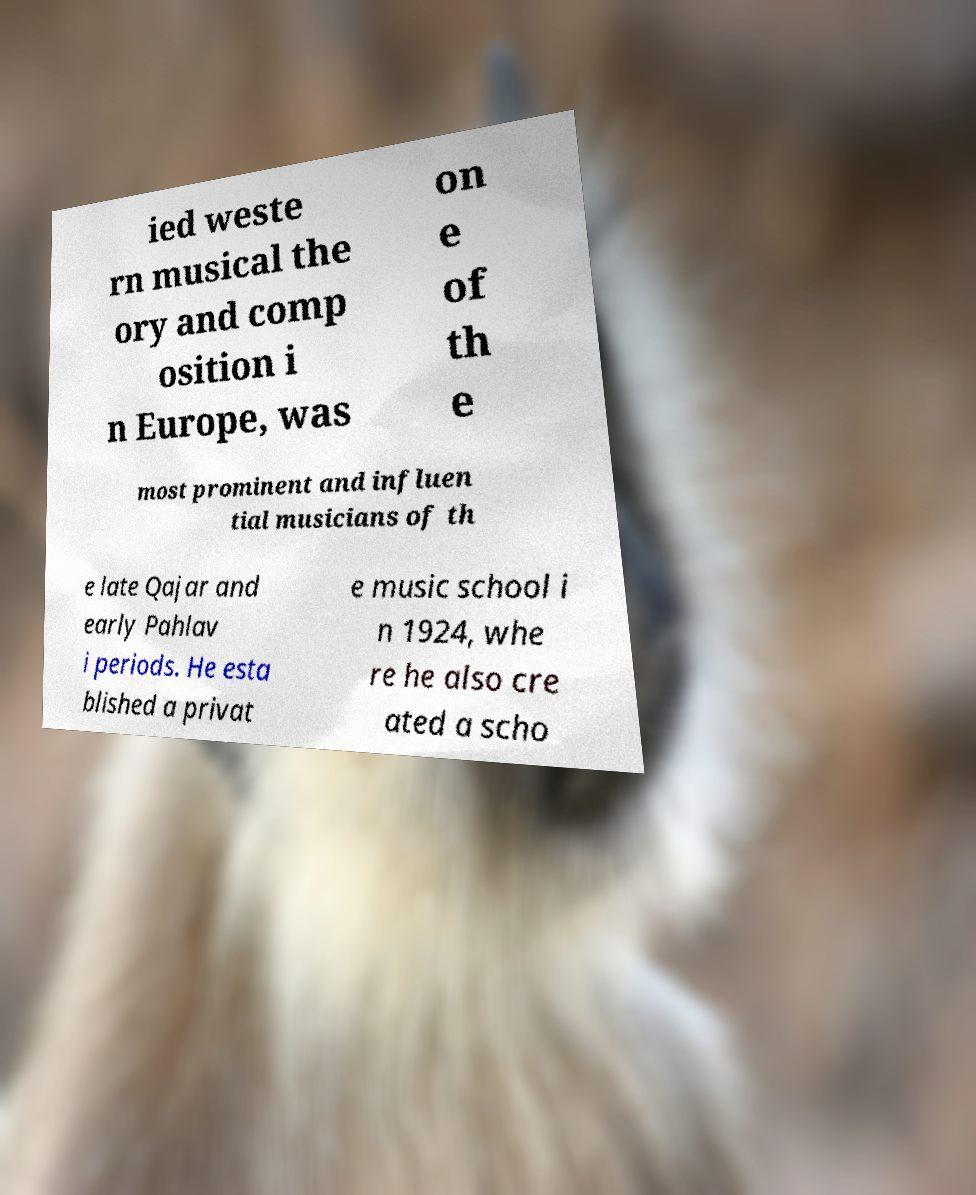Could you assist in decoding the text presented in this image and type it out clearly? ied weste rn musical the ory and comp osition i n Europe, was on e of th e most prominent and influen tial musicians of th e late Qajar and early Pahlav i periods. He esta blished a privat e music school i n 1924, whe re he also cre ated a scho 